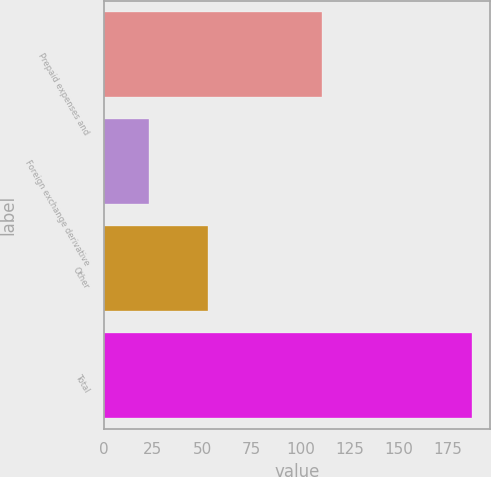Convert chart. <chart><loc_0><loc_0><loc_500><loc_500><bar_chart><fcel>Prepaid expenses and<fcel>Foreign exchange derivative<fcel>Other<fcel>Total<nl><fcel>111<fcel>23<fcel>53<fcel>187<nl></chart> 